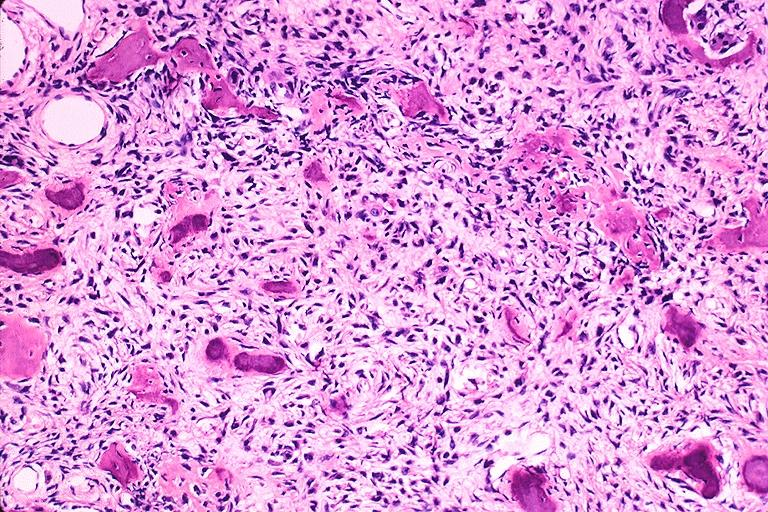does muscle show cemento-ossifying fibroma?
Answer the question using a single word or phrase. No 